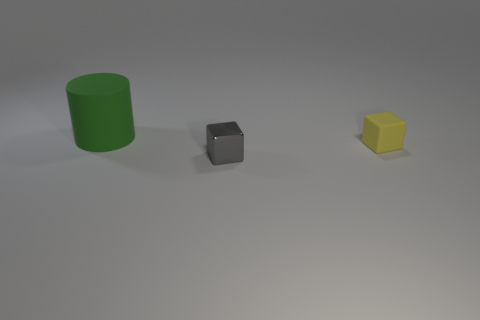Is the material of the yellow block the same as the big green thing?
Make the answer very short. Yes. There is a thing that is to the left of the small cube that is left of the tiny yellow object; are there any gray metal objects behind it?
Your answer should be very brief. No. What number of other things are the same shape as the large object?
Offer a terse response. 0. What is the shape of the thing that is both on the right side of the cylinder and behind the gray metallic cube?
Provide a short and direct response. Cube. What is the color of the rubber thing on the right side of the object behind the matte thing in front of the big cylinder?
Provide a succinct answer. Yellow. Are there more tiny shiny objects that are on the right side of the green rubber cylinder than small blocks right of the tiny yellow block?
Offer a terse response. Yes. What number of other things are the same size as the yellow thing?
Give a very brief answer. 1. There is a block to the right of the thing in front of the small yellow rubber block; what is it made of?
Ensure brevity in your answer.  Rubber. Are there any blocks behind the tiny yellow matte block?
Offer a very short reply. No. Are there more yellow matte blocks behind the big green object than tiny matte things?
Your answer should be very brief. No. 